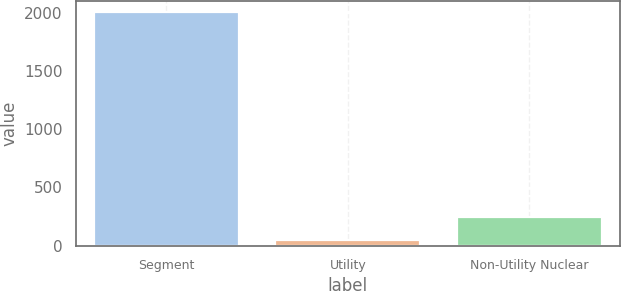Convert chart. <chart><loc_0><loc_0><loc_500><loc_500><bar_chart><fcel>Segment<fcel>Utility<fcel>Non-Utility Nuclear<nl><fcel>2008<fcel>48<fcel>244<nl></chart> 